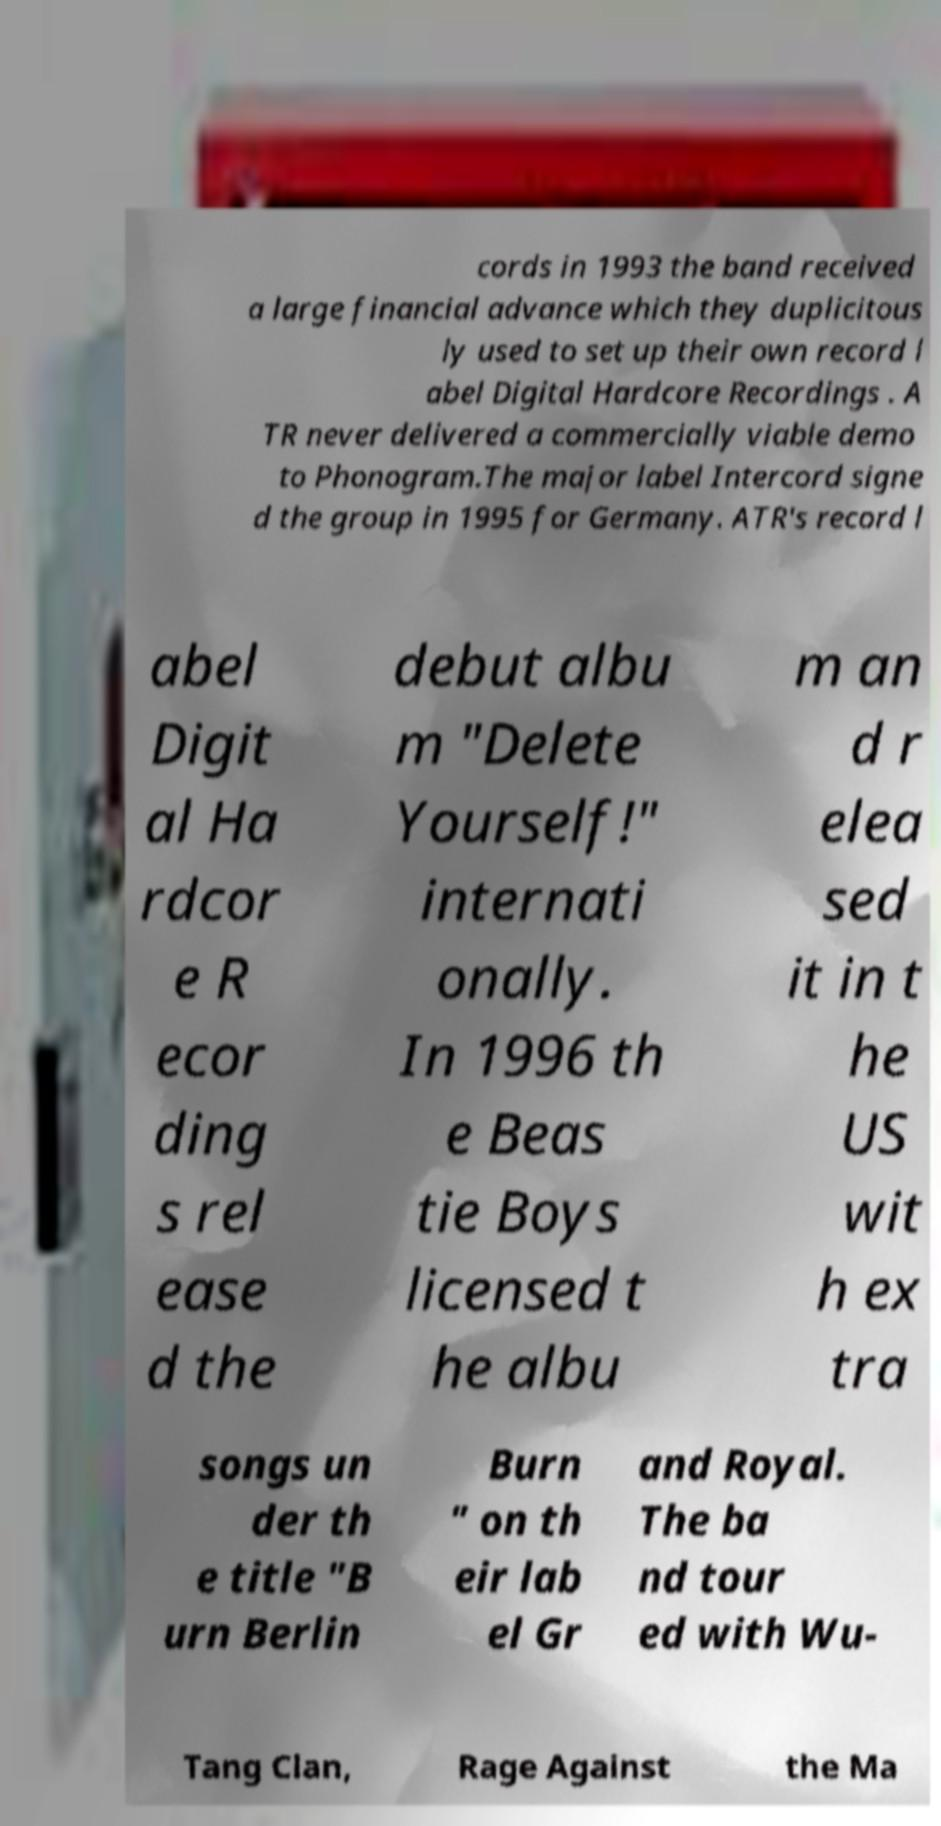Can you read and provide the text displayed in the image?This photo seems to have some interesting text. Can you extract and type it out for me? cords in 1993 the band received a large financial advance which they duplicitous ly used to set up their own record l abel Digital Hardcore Recordings . A TR never delivered a commercially viable demo to Phonogram.The major label Intercord signe d the group in 1995 for Germany. ATR's record l abel Digit al Ha rdcor e R ecor ding s rel ease d the debut albu m "Delete Yourself!" internati onally. In 1996 th e Beas tie Boys licensed t he albu m an d r elea sed it in t he US wit h ex tra songs un der th e title "B urn Berlin Burn " on th eir lab el Gr and Royal. The ba nd tour ed with Wu- Tang Clan, Rage Against the Ma 